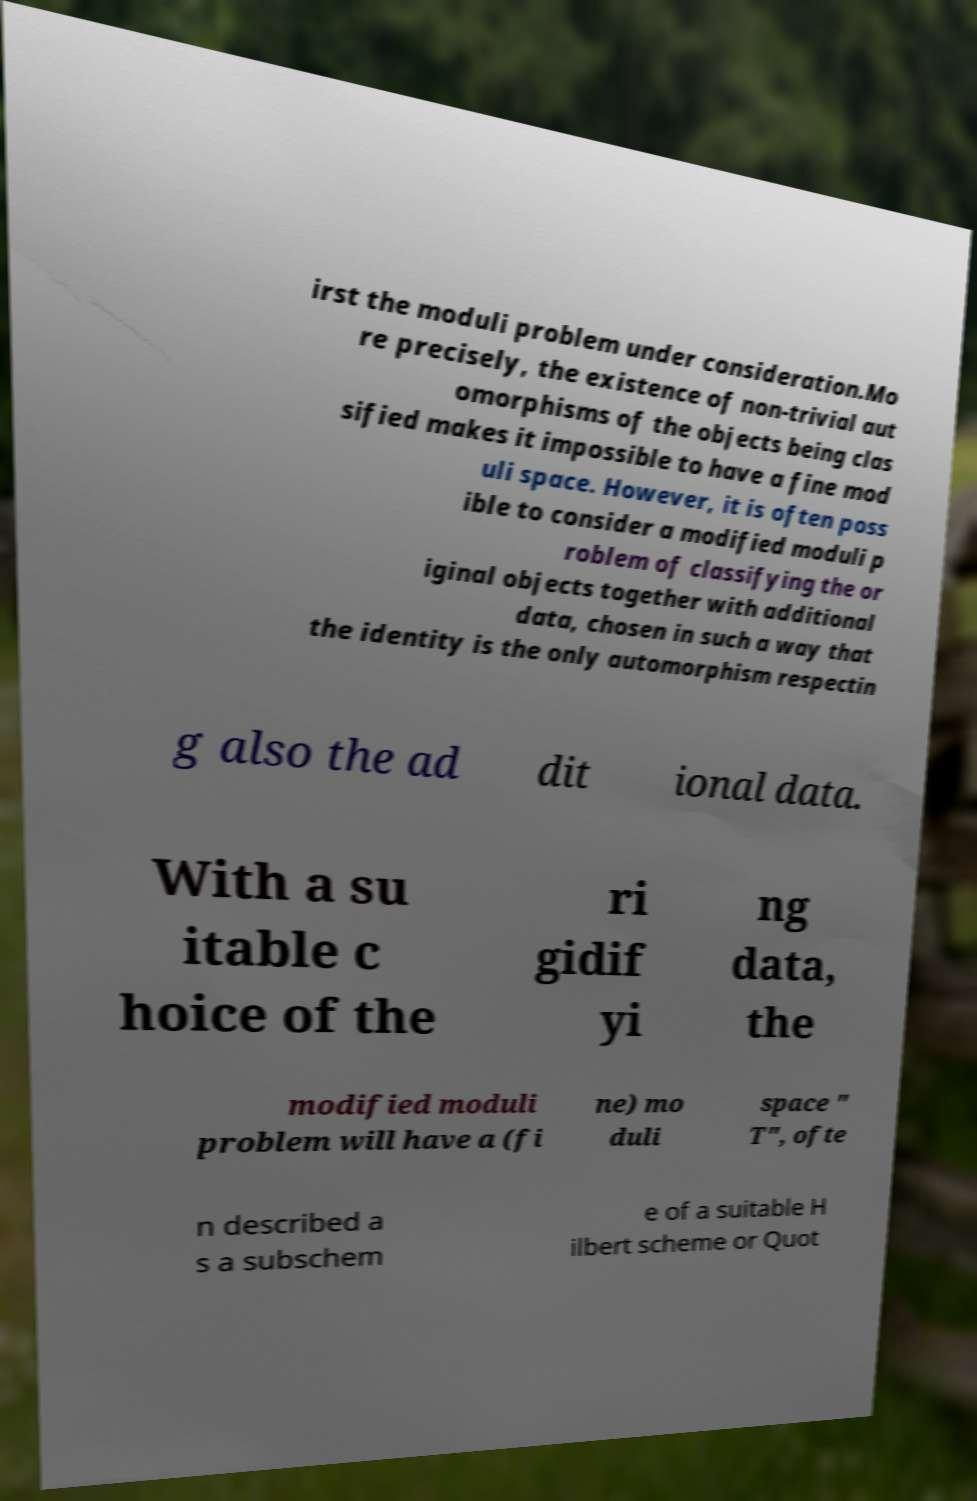What messages or text are displayed in this image? I need them in a readable, typed format. irst the moduli problem under consideration.Mo re precisely, the existence of non-trivial aut omorphisms of the objects being clas sified makes it impossible to have a fine mod uli space. However, it is often poss ible to consider a modified moduli p roblem of classifying the or iginal objects together with additional data, chosen in such a way that the identity is the only automorphism respectin g also the ad dit ional data. With a su itable c hoice of the ri gidif yi ng data, the modified moduli problem will have a (fi ne) mo duli space " T", ofte n described a s a subschem e of a suitable H ilbert scheme or Quot 